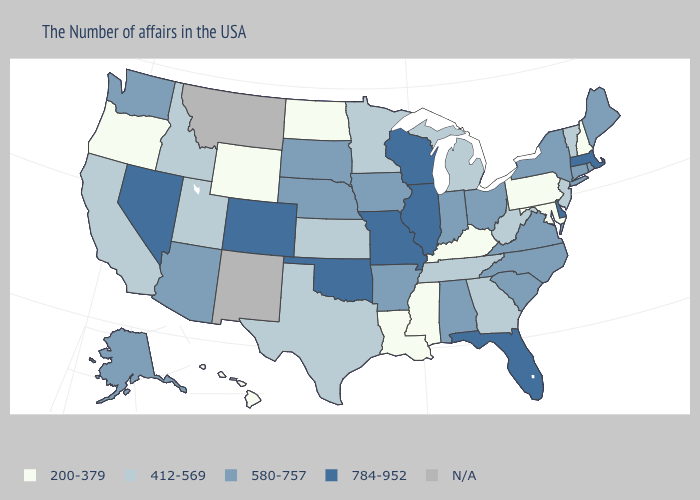Name the states that have a value in the range N/A?
Quick response, please. New Mexico, Montana. What is the value of Minnesota?
Keep it brief. 412-569. What is the highest value in the USA?
Be succinct. 784-952. Does Massachusetts have the highest value in the USA?
Concise answer only. Yes. What is the value of Ohio?
Give a very brief answer. 580-757. Name the states that have a value in the range 580-757?
Short answer required. Maine, Rhode Island, Connecticut, New York, Virginia, North Carolina, South Carolina, Ohio, Indiana, Alabama, Arkansas, Iowa, Nebraska, South Dakota, Arizona, Washington, Alaska. What is the lowest value in the Northeast?
Write a very short answer. 200-379. What is the value of Maryland?
Concise answer only. 200-379. Which states have the lowest value in the USA?
Concise answer only. New Hampshire, Maryland, Pennsylvania, Kentucky, Mississippi, Louisiana, North Dakota, Wyoming, Oregon, Hawaii. Does Minnesota have the lowest value in the MidWest?
Keep it brief. No. Which states have the lowest value in the USA?
Short answer required. New Hampshire, Maryland, Pennsylvania, Kentucky, Mississippi, Louisiana, North Dakota, Wyoming, Oregon, Hawaii. Does South Dakota have the lowest value in the USA?
Short answer required. No. What is the value of Nebraska?
Short answer required. 580-757. What is the lowest value in the South?
Give a very brief answer. 200-379. 